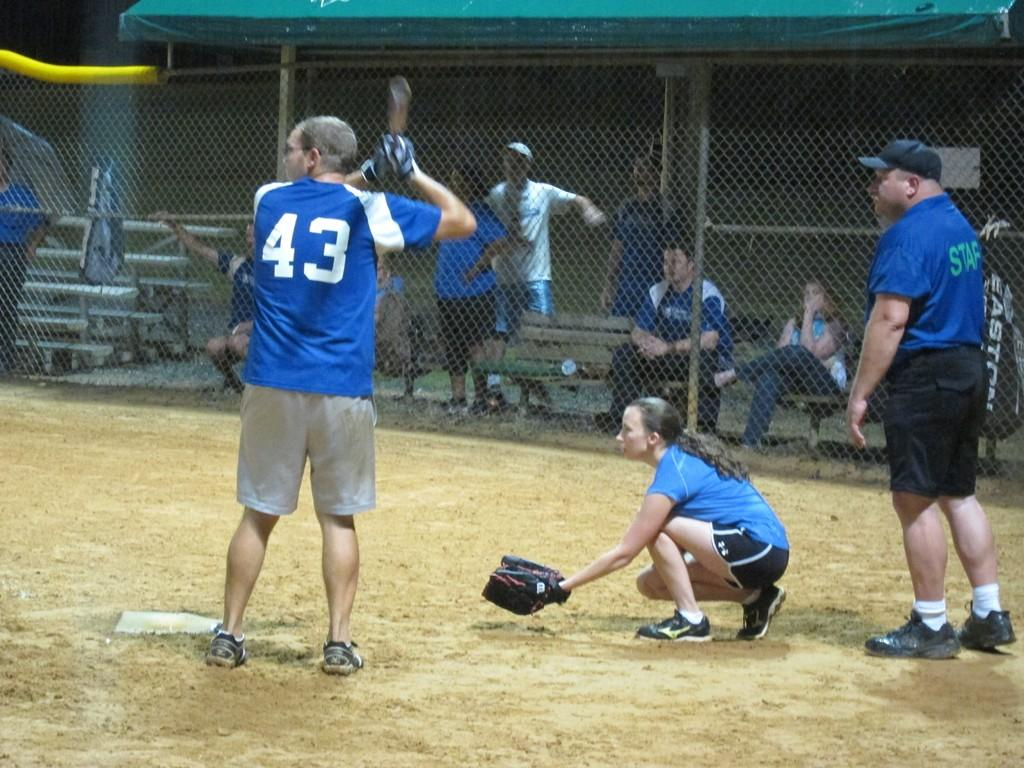<image>
Present a compact description of the photo's key features. Man wearing a number 43 getting ready to bat. 